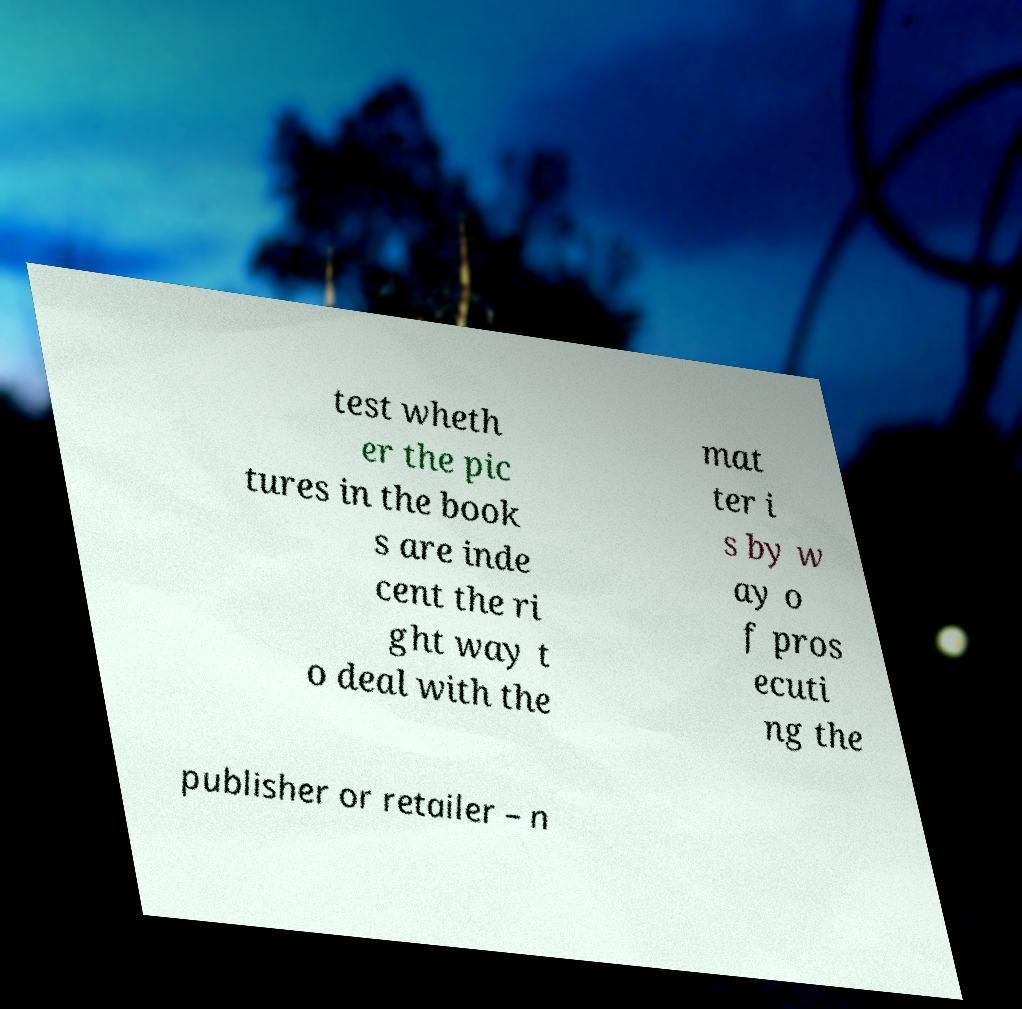Can you accurately transcribe the text from the provided image for me? test wheth er the pic tures in the book s are inde cent the ri ght way t o deal with the mat ter i s by w ay o f pros ecuti ng the publisher or retailer – n 